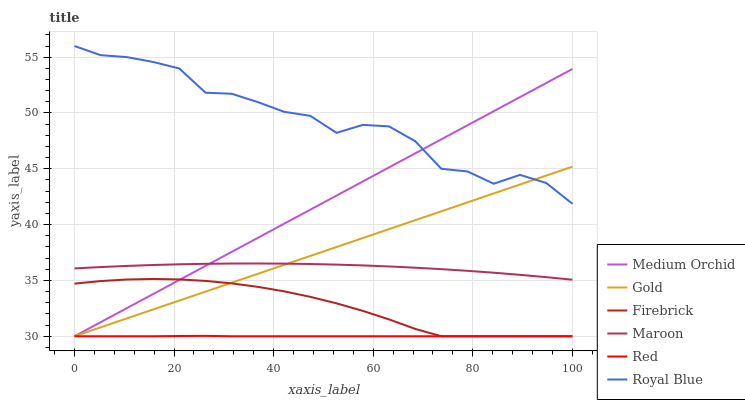Does Red have the minimum area under the curve?
Answer yes or no. Yes. Does Royal Blue have the maximum area under the curve?
Answer yes or no. Yes. Does Firebrick have the minimum area under the curve?
Answer yes or no. No. Does Firebrick have the maximum area under the curve?
Answer yes or no. No. Is Medium Orchid the smoothest?
Answer yes or no. Yes. Is Royal Blue the roughest?
Answer yes or no. Yes. Is Firebrick the smoothest?
Answer yes or no. No. Is Firebrick the roughest?
Answer yes or no. No. Does Gold have the lowest value?
Answer yes or no. Yes. Does Maroon have the lowest value?
Answer yes or no. No. Does Royal Blue have the highest value?
Answer yes or no. Yes. Does Firebrick have the highest value?
Answer yes or no. No. Is Red less than Royal Blue?
Answer yes or no. Yes. Is Royal Blue greater than Maroon?
Answer yes or no. Yes. Does Medium Orchid intersect Firebrick?
Answer yes or no. Yes. Is Medium Orchid less than Firebrick?
Answer yes or no. No. Is Medium Orchid greater than Firebrick?
Answer yes or no. No. Does Red intersect Royal Blue?
Answer yes or no. No. 